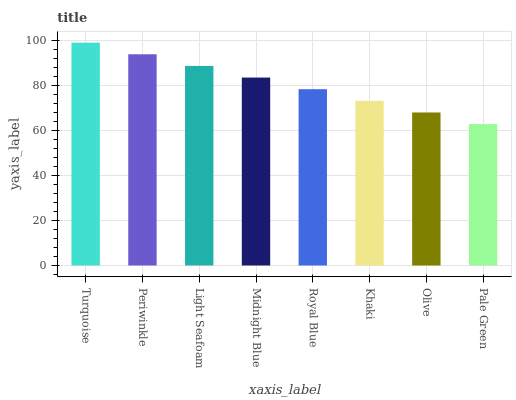Is Pale Green the minimum?
Answer yes or no. Yes. Is Turquoise the maximum?
Answer yes or no. Yes. Is Periwinkle the minimum?
Answer yes or no. No. Is Periwinkle the maximum?
Answer yes or no. No. Is Turquoise greater than Periwinkle?
Answer yes or no. Yes. Is Periwinkle less than Turquoise?
Answer yes or no. Yes. Is Periwinkle greater than Turquoise?
Answer yes or no. No. Is Turquoise less than Periwinkle?
Answer yes or no. No. Is Midnight Blue the high median?
Answer yes or no. Yes. Is Royal Blue the low median?
Answer yes or no. Yes. Is Royal Blue the high median?
Answer yes or no. No. Is Olive the low median?
Answer yes or no. No. 